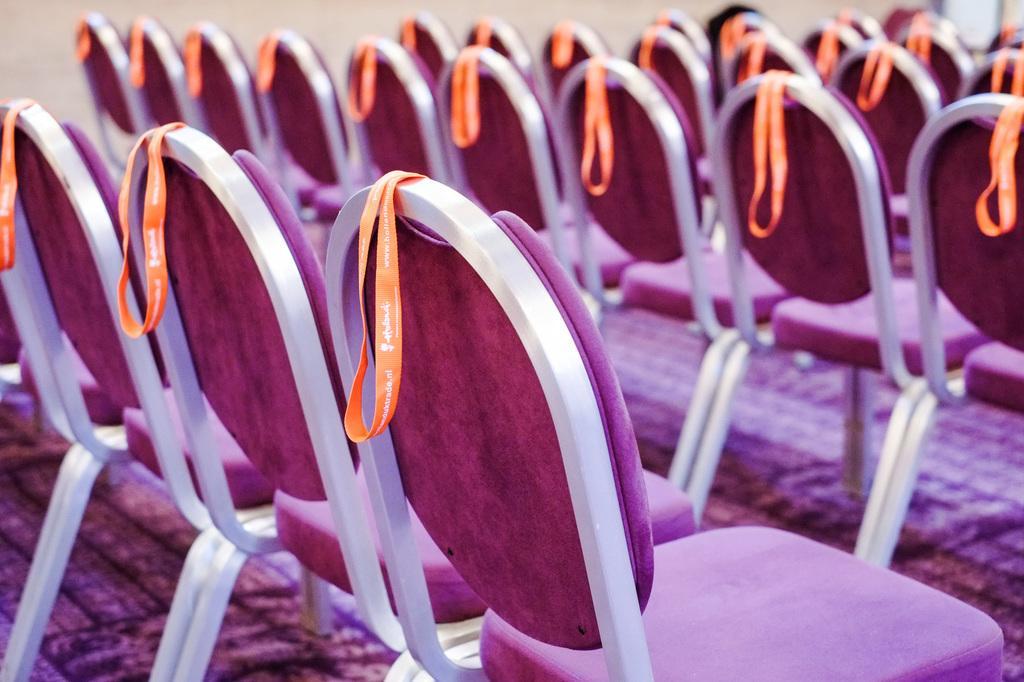Can you describe this image briefly? Here we can see tags on the chairs. In the background there is a wall. 